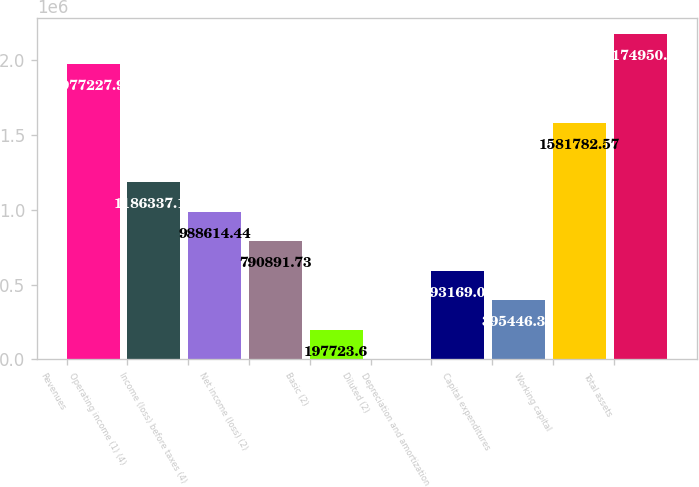Convert chart to OTSL. <chart><loc_0><loc_0><loc_500><loc_500><bar_chart><fcel>Revenues<fcel>Operating income (1) (4)<fcel>Income (loss) before taxes (4)<fcel>Net income (loss) (2)<fcel>Basic (2)<fcel>Diluted (2)<fcel>Depreciation and amortization<fcel>Capital expenditures<fcel>Working capital<fcel>Total assets<nl><fcel>1.97723e+06<fcel>1.18634e+06<fcel>988614<fcel>790892<fcel>197724<fcel>0.89<fcel>593169<fcel>395446<fcel>1.58178e+06<fcel>2.17495e+06<nl></chart> 